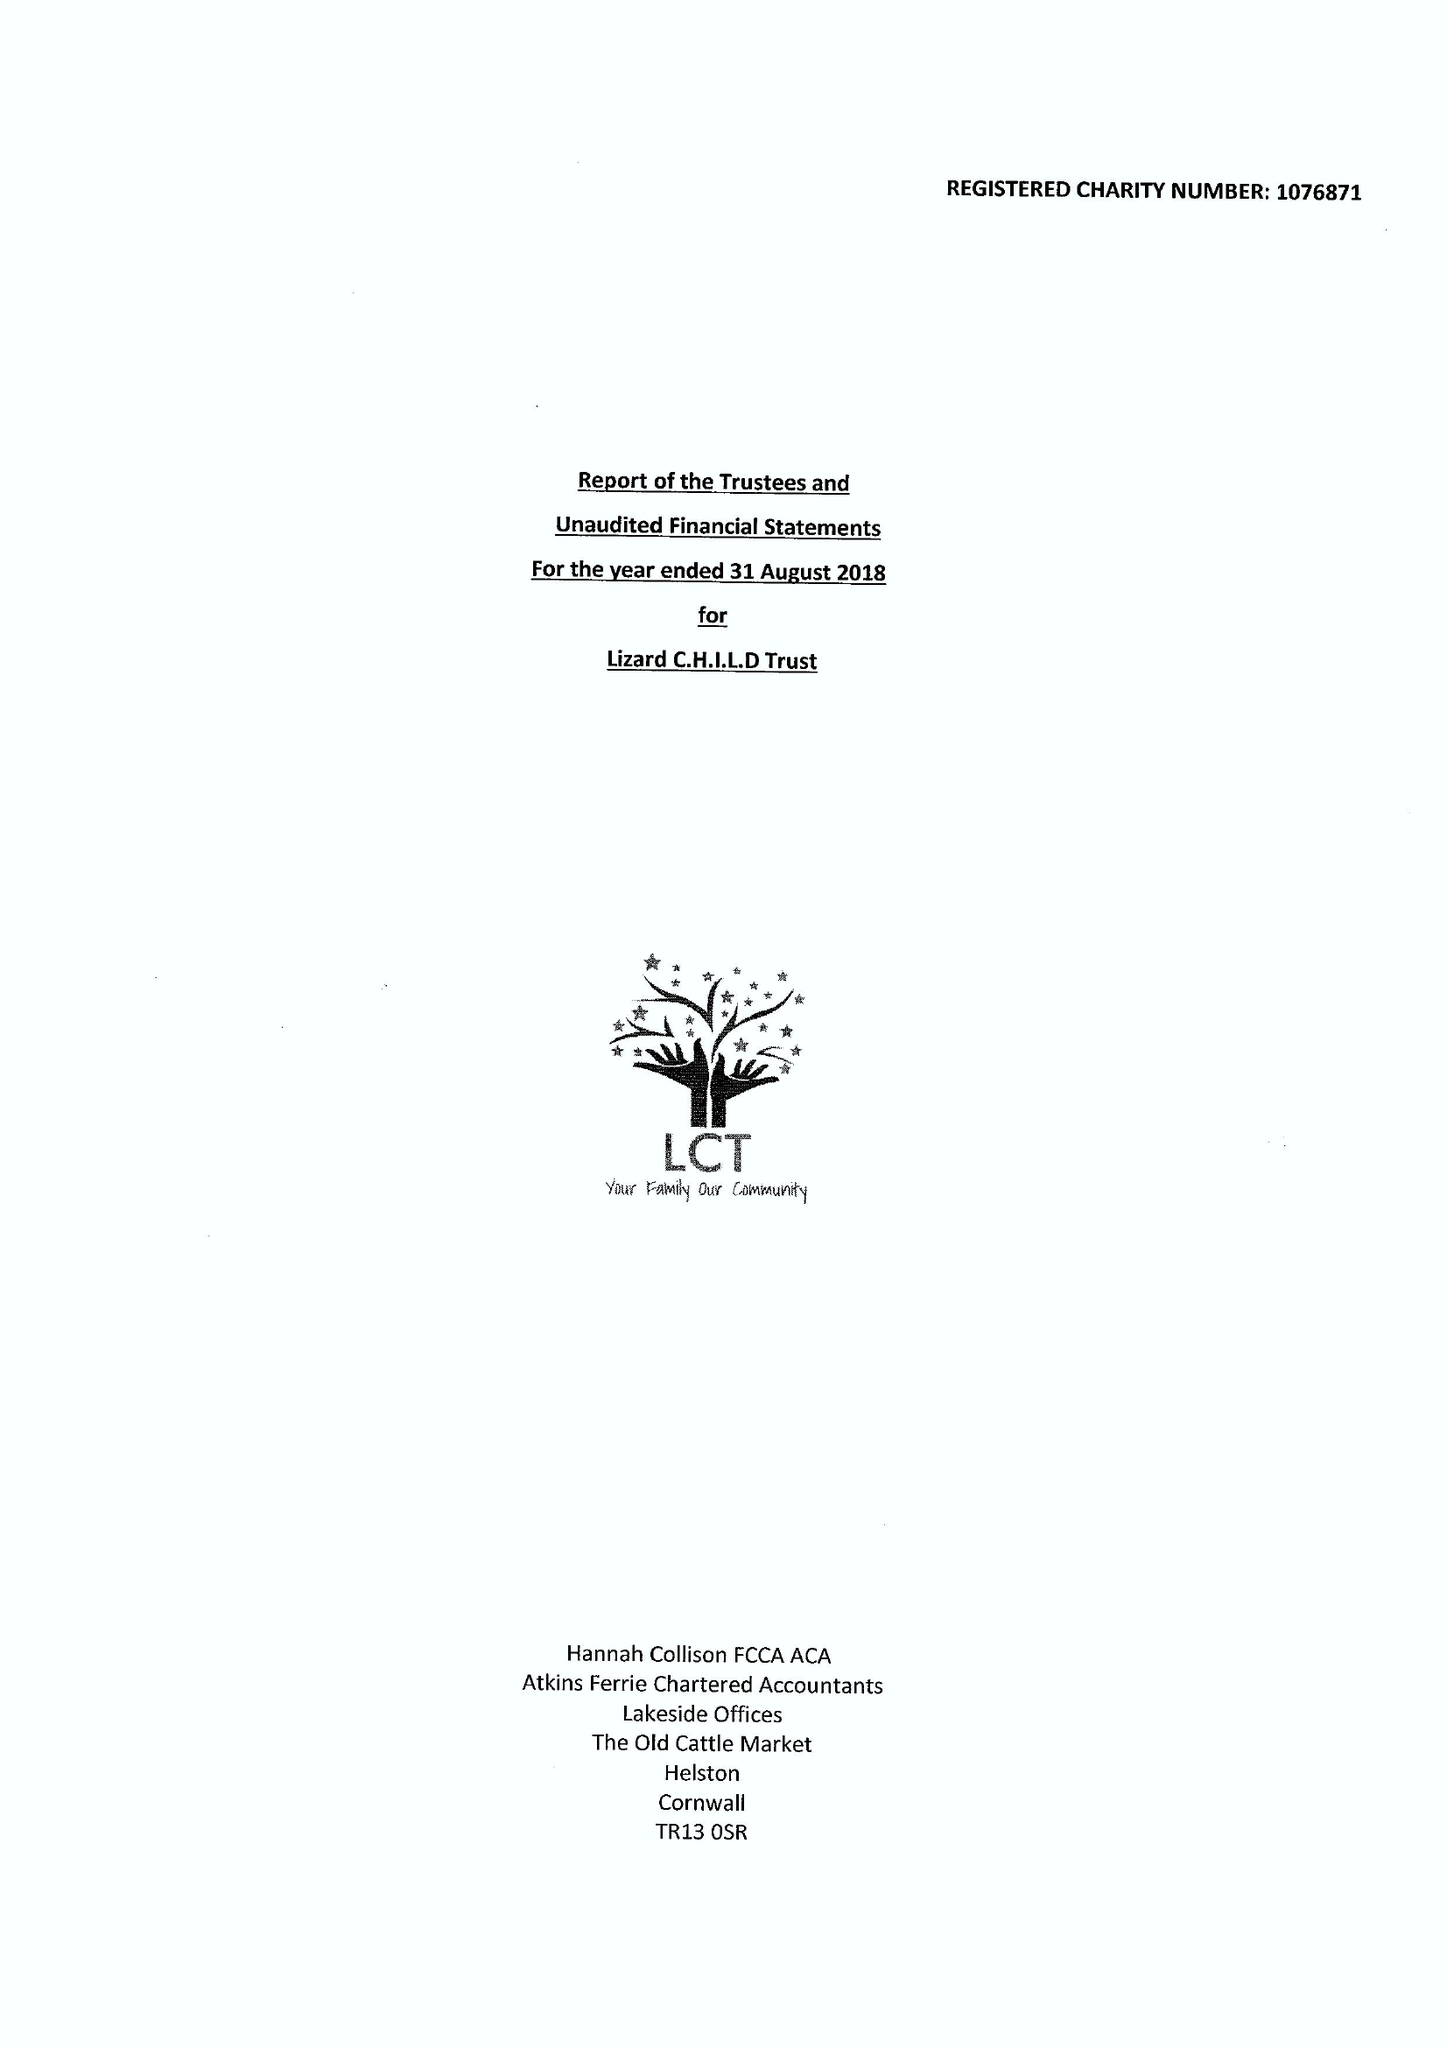What is the value for the spending_annually_in_british_pounds?
Answer the question using a single word or phrase. 246511.00 